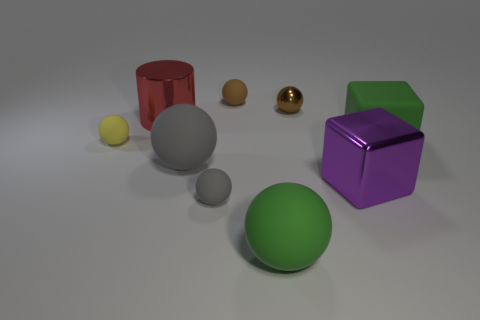Subtract 1 spheres. How many spheres are left? 5 Subtract all green balls. How many balls are left? 5 Subtract all gray spheres. How many spheres are left? 4 Subtract all cyan balls. Subtract all purple cubes. How many balls are left? 6 Add 1 yellow matte spheres. How many objects exist? 10 Subtract all cylinders. How many objects are left? 8 Subtract 0 purple spheres. How many objects are left? 9 Subtract all cubes. Subtract all big green things. How many objects are left? 5 Add 3 brown metallic things. How many brown metallic things are left? 4 Add 3 green balls. How many green balls exist? 4 